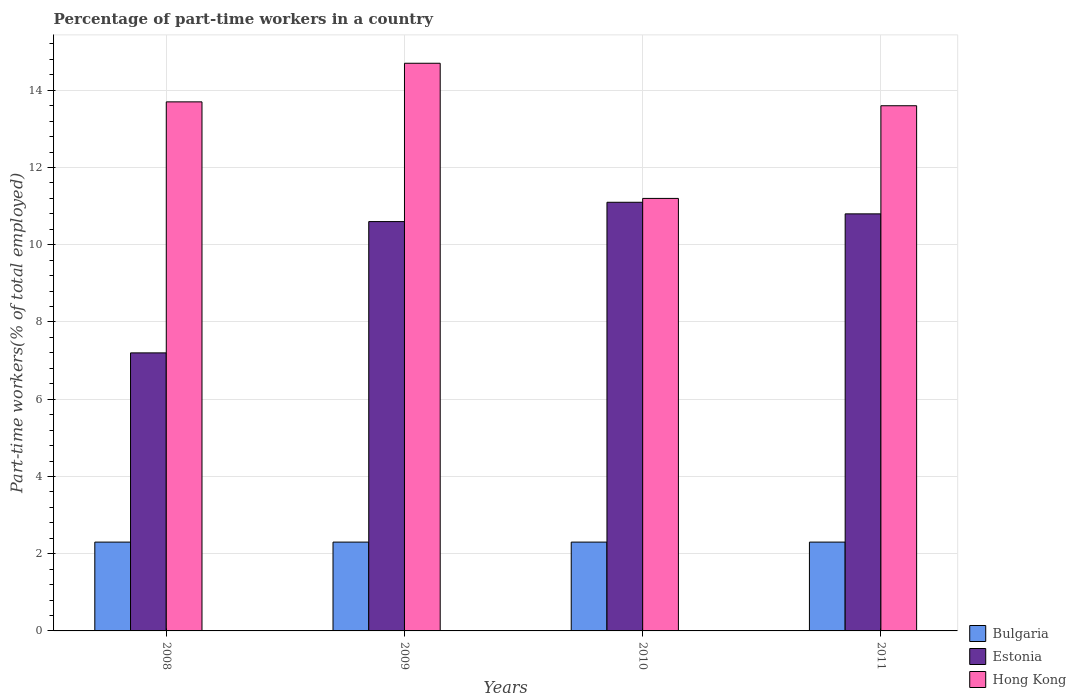How many different coloured bars are there?
Your answer should be very brief. 3. How many groups of bars are there?
Your answer should be very brief. 4. Are the number of bars per tick equal to the number of legend labels?
Your answer should be very brief. Yes. How many bars are there on the 2nd tick from the right?
Provide a short and direct response. 3. What is the label of the 1st group of bars from the left?
Your answer should be compact. 2008. What is the percentage of part-time workers in Hong Kong in 2008?
Give a very brief answer. 13.7. Across all years, what is the maximum percentage of part-time workers in Estonia?
Your response must be concise. 11.1. Across all years, what is the minimum percentage of part-time workers in Estonia?
Your answer should be very brief. 7.2. In which year was the percentage of part-time workers in Hong Kong minimum?
Provide a short and direct response. 2010. What is the total percentage of part-time workers in Bulgaria in the graph?
Your answer should be very brief. 9.2. What is the difference between the percentage of part-time workers in Estonia in 2008 and that in 2010?
Offer a terse response. -3.9. What is the difference between the percentage of part-time workers in Estonia in 2008 and the percentage of part-time workers in Bulgaria in 2011?
Offer a very short reply. 4.9. What is the average percentage of part-time workers in Estonia per year?
Ensure brevity in your answer.  9.93. In the year 2009, what is the difference between the percentage of part-time workers in Bulgaria and percentage of part-time workers in Estonia?
Provide a short and direct response. -8.3. Is the difference between the percentage of part-time workers in Bulgaria in 2008 and 2009 greater than the difference between the percentage of part-time workers in Estonia in 2008 and 2009?
Make the answer very short. Yes. What is the difference between the highest and the second highest percentage of part-time workers in Bulgaria?
Ensure brevity in your answer.  0. Is the sum of the percentage of part-time workers in Hong Kong in 2008 and 2010 greater than the maximum percentage of part-time workers in Bulgaria across all years?
Ensure brevity in your answer.  Yes. What does the 2nd bar from the left in 2011 represents?
Your answer should be very brief. Estonia. What does the 3rd bar from the right in 2009 represents?
Your answer should be very brief. Bulgaria. What is the difference between two consecutive major ticks on the Y-axis?
Provide a succinct answer. 2. Does the graph contain grids?
Your answer should be very brief. Yes. How many legend labels are there?
Provide a succinct answer. 3. What is the title of the graph?
Make the answer very short. Percentage of part-time workers in a country. Does "Small states" appear as one of the legend labels in the graph?
Offer a very short reply. No. What is the label or title of the X-axis?
Offer a terse response. Years. What is the label or title of the Y-axis?
Offer a terse response. Part-time workers(% of total employed). What is the Part-time workers(% of total employed) in Bulgaria in 2008?
Your response must be concise. 2.3. What is the Part-time workers(% of total employed) of Estonia in 2008?
Your response must be concise. 7.2. What is the Part-time workers(% of total employed) in Hong Kong in 2008?
Offer a very short reply. 13.7. What is the Part-time workers(% of total employed) of Bulgaria in 2009?
Ensure brevity in your answer.  2.3. What is the Part-time workers(% of total employed) in Estonia in 2009?
Offer a terse response. 10.6. What is the Part-time workers(% of total employed) of Hong Kong in 2009?
Offer a terse response. 14.7. What is the Part-time workers(% of total employed) of Bulgaria in 2010?
Provide a succinct answer. 2.3. What is the Part-time workers(% of total employed) of Estonia in 2010?
Offer a very short reply. 11.1. What is the Part-time workers(% of total employed) of Hong Kong in 2010?
Your response must be concise. 11.2. What is the Part-time workers(% of total employed) in Bulgaria in 2011?
Your response must be concise. 2.3. What is the Part-time workers(% of total employed) in Estonia in 2011?
Make the answer very short. 10.8. What is the Part-time workers(% of total employed) of Hong Kong in 2011?
Provide a short and direct response. 13.6. Across all years, what is the maximum Part-time workers(% of total employed) in Bulgaria?
Provide a succinct answer. 2.3. Across all years, what is the maximum Part-time workers(% of total employed) in Estonia?
Make the answer very short. 11.1. Across all years, what is the maximum Part-time workers(% of total employed) in Hong Kong?
Ensure brevity in your answer.  14.7. Across all years, what is the minimum Part-time workers(% of total employed) in Bulgaria?
Provide a short and direct response. 2.3. Across all years, what is the minimum Part-time workers(% of total employed) in Estonia?
Ensure brevity in your answer.  7.2. Across all years, what is the minimum Part-time workers(% of total employed) in Hong Kong?
Offer a very short reply. 11.2. What is the total Part-time workers(% of total employed) of Estonia in the graph?
Your answer should be very brief. 39.7. What is the total Part-time workers(% of total employed) in Hong Kong in the graph?
Offer a very short reply. 53.2. What is the difference between the Part-time workers(% of total employed) of Bulgaria in 2008 and that in 2009?
Ensure brevity in your answer.  0. What is the difference between the Part-time workers(% of total employed) of Estonia in 2008 and that in 2009?
Provide a succinct answer. -3.4. What is the difference between the Part-time workers(% of total employed) of Bulgaria in 2008 and that in 2010?
Your answer should be very brief. 0. What is the difference between the Part-time workers(% of total employed) in Estonia in 2008 and that in 2010?
Your answer should be compact. -3.9. What is the difference between the Part-time workers(% of total employed) in Bulgaria in 2008 and that in 2011?
Provide a succinct answer. 0. What is the difference between the Part-time workers(% of total employed) in Hong Kong in 2008 and that in 2011?
Your answer should be compact. 0.1. What is the difference between the Part-time workers(% of total employed) of Hong Kong in 2009 and that in 2010?
Keep it short and to the point. 3.5. What is the difference between the Part-time workers(% of total employed) of Bulgaria in 2009 and that in 2011?
Your answer should be very brief. 0. What is the difference between the Part-time workers(% of total employed) of Hong Kong in 2009 and that in 2011?
Provide a succinct answer. 1.1. What is the difference between the Part-time workers(% of total employed) in Estonia in 2010 and that in 2011?
Offer a very short reply. 0.3. What is the difference between the Part-time workers(% of total employed) of Hong Kong in 2010 and that in 2011?
Your answer should be compact. -2.4. What is the difference between the Part-time workers(% of total employed) in Bulgaria in 2008 and the Part-time workers(% of total employed) in Estonia in 2009?
Provide a succinct answer. -8.3. What is the difference between the Part-time workers(% of total employed) in Bulgaria in 2008 and the Part-time workers(% of total employed) in Hong Kong in 2010?
Your answer should be compact. -8.9. What is the difference between the Part-time workers(% of total employed) in Estonia in 2008 and the Part-time workers(% of total employed) in Hong Kong in 2010?
Give a very brief answer. -4. What is the difference between the Part-time workers(% of total employed) of Bulgaria in 2008 and the Part-time workers(% of total employed) of Hong Kong in 2011?
Give a very brief answer. -11.3. What is the difference between the Part-time workers(% of total employed) of Estonia in 2008 and the Part-time workers(% of total employed) of Hong Kong in 2011?
Give a very brief answer. -6.4. What is the difference between the Part-time workers(% of total employed) of Bulgaria in 2009 and the Part-time workers(% of total employed) of Estonia in 2010?
Make the answer very short. -8.8. What is the difference between the Part-time workers(% of total employed) in Estonia in 2009 and the Part-time workers(% of total employed) in Hong Kong in 2010?
Your answer should be very brief. -0.6. What is the difference between the Part-time workers(% of total employed) in Bulgaria in 2009 and the Part-time workers(% of total employed) in Hong Kong in 2011?
Give a very brief answer. -11.3. What is the difference between the Part-time workers(% of total employed) of Estonia in 2010 and the Part-time workers(% of total employed) of Hong Kong in 2011?
Offer a very short reply. -2.5. What is the average Part-time workers(% of total employed) in Bulgaria per year?
Provide a short and direct response. 2.3. What is the average Part-time workers(% of total employed) in Estonia per year?
Provide a short and direct response. 9.93. In the year 2008, what is the difference between the Part-time workers(% of total employed) in Bulgaria and Part-time workers(% of total employed) in Estonia?
Offer a terse response. -4.9. In the year 2008, what is the difference between the Part-time workers(% of total employed) in Bulgaria and Part-time workers(% of total employed) in Hong Kong?
Your answer should be very brief. -11.4. In the year 2008, what is the difference between the Part-time workers(% of total employed) of Estonia and Part-time workers(% of total employed) of Hong Kong?
Your response must be concise. -6.5. In the year 2009, what is the difference between the Part-time workers(% of total employed) of Bulgaria and Part-time workers(% of total employed) of Estonia?
Ensure brevity in your answer.  -8.3. In the year 2010, what is the difference between the Part-time workers(% of total employed) in Bulgaria and Part-time workers(% of total employed) in Hong Kong?
Give a very brief answer. -8.9. What is the ratio of the Part-time workers(% of total employed) of Estonia in 2008 to that in 2009?
Offer a very short reply. 0.68. What is the ratio of the Part-time workers(% of total employed) of Hong Kong in 2008 to that in 2009?
Offer a terse response. 0.93. What is the ratio of the Part-time workers(% of total employed) of Estonia in 2008 to that in 2010?
Give a very brief answer. 0.65. What is the ratio of the Part-time workers(% of total employed) in Hong Kong in 2008 to that in 2010?
Give a very brief answer. 1.22. What is the ratio of the Part-time workers(% of total employed) in Estonia in 2008 to that in 2011?
Offer a terse response. 0.67. What is the ratio of the Part-time workers(% of total employed) of Hong Kong in 2008 to that in 2011?
Your answer should be compact. 1.01. What is the ratio of the Part-time workers(% of total employed) of Bulgaria in 2009 to that in 2010?
Give a very brief answer. 1. What is the ratio of the Part-time workers(% of total employed) in Estonia in 2009 to that in 2010?
Provide a succinct answer. 0.95. What is the ratio of the Part-time workers(% of total employed) of Hong Kong in 2009 to that in 2010?
Keep it short and to the point. 1.31. What is the ratio of the Part-time workers(% of total employed) in Estonia in 2009 to that in 2011?
Keep it short and to the point. 0.98. What is the ratio of the Part-time workers(% of total employed) in Hong Kong in 2009 to that in 2011?
Ensure brevity in your answer.  1.08. What is the ratio of the Part-time workers(% of total employed) in Estonia in 2010 to that in 2011?
Keep it short and to the point. 1.03. What is the ratio of the Part-time workers(% of total employed) in Hong Kong in 2010 to that in 2011?
Give a very brief answer. 0.82. What is the difference between the highest and the second highest Part-time workers(% of total employed) of Hong Kong?
Provide a short and direct response. 1. What is the difference between the highest and the lowest Part-time workers(% of total employed) of Bulgaria?
Provide a succinct answer. 0. 